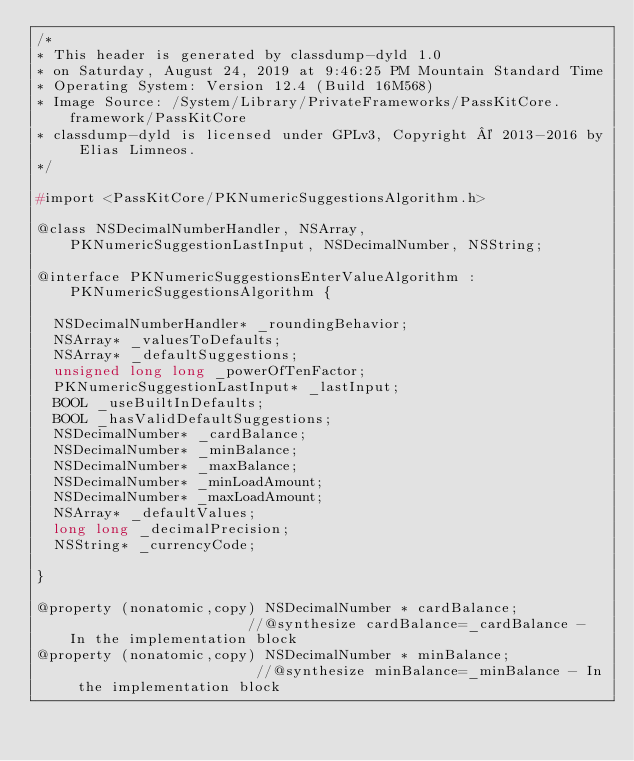Convert code to text. <code><loc_0><loc_0><loc_500><loc_500><_C_>/*
* This header is generated by classdump-dyld 1.0
* on Saturday, August 24, 2019 at 9:46:25 PM Mountain Standard Time
* Operating System: Version 12.4 (Build 16M568)
* Image Source: /System/Library/PrivateFrameworks/PassKitCore.framework/PassKitCore
* classdump-dyld is licensed under GPLv3, Copyright © 2013-2016 by Elias Limneos.
*/

#import <PassKitCore/PKNumericSuggestionsAlgorithm.h>

@class NSDecimalNumberHandler, NSArray, PKNumericSuggestionLastInput, NSDecimalNumber, NSString;

@interface PKNumericSuggestionsEnterValueAlgorithm : PKNumericSuggestionsAlgorithm {

	NSDecimalNumberHandler* _roundingBehavior;
	NSArray* _valuesToDefaults;
	NSArray* _defaultSuggestions;
	unsigned long long _powerOfTenFactor;
	PKNumericSuggestionLastInput* _lastInput;
	BOOL _useBuiltInDefaults;
	BOOL _hasValidDefaultSuggestions;
	NSDecimalNumber* _cardBalance;
	NSDecimalNumber* _minBalance;
	NSDecimalNumber* _maxBalance;
	NSDecimalNumber* _minLoadAmount;
	NSDecimalNumber* _maxLoadAmount;
	NSArray* _defaultValues;
	long long _decimalPrecision;
	NSString* _currencyCode;

}

@property (nonatomic,copy) NSDecimalNumber * cardBalance;                      //@synthesize cardBalance=_cardBalance - In the implementation block
@property (nonatomic,copy) NSDecimalNumber * minBalance;                       //@synthesize minBalance=_minBalance - In the implementation block</code> 